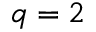Convert formula to latex. <formula><loc_0><loc_0><loc_500><loc_500>q = 2</formula> 